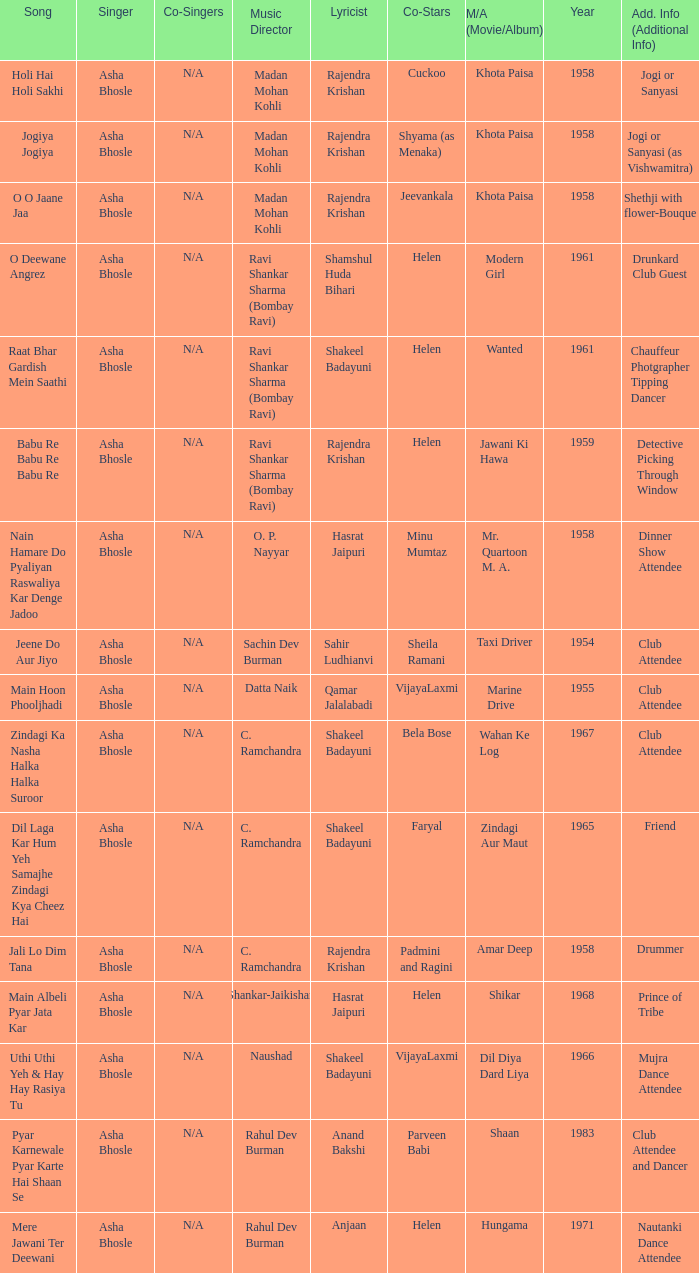What movie did Vijayalaxmi Co-star in and Shakeel Badayuni write the lyrics? Dil Diya Dard Liya. 